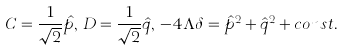<formula> <loc_0><loc_0><loc_500><loc_500>C = \frac { 1 } { \sqrt { 2 } } \hat { p } , \, D = \frac { 1 } { \sqrt { 2 } } \hat { q } , \, - 4 \Lambda \delta = \hat { p } ^ { 2 } + \hat { q } ^ { 2 } + c o n s t .</formula> 